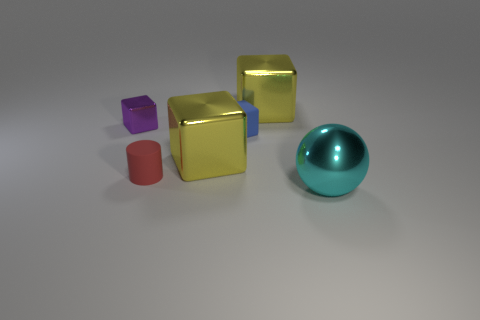Subtract all yellow cubes. How many were subtracted if there are1yellow cubes left? 1 Add 3 tiny brown cylinders. How many objects exist? 9 Subtract all blocks. How many objects are left? 2 Add 1 large metal spheres. How many large metal spheres are left? 2 Add 5 big metal blocks. How many big metal blocks exist? 7 Subtract 0 brown balls. How many objects are left? 6 Subtract all green cylinders. Subtract all small cubes. How many objects are left? 4 